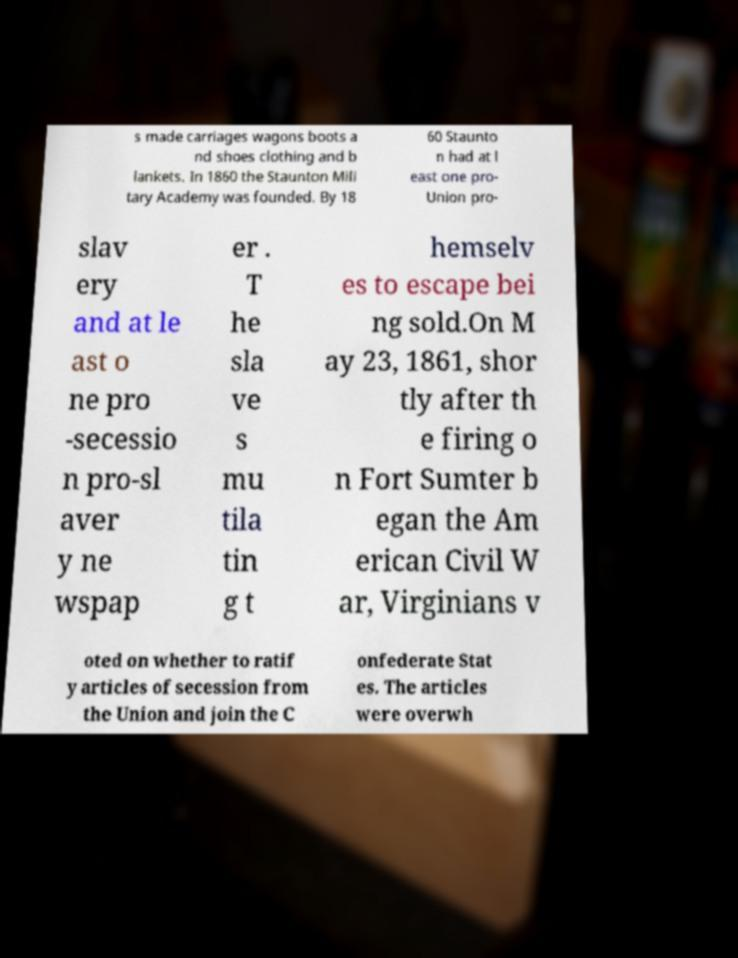For documentation purposes, I need the text within this image transcribed. Could you provide that? s made carriages wagons boots a nd shoes clothing and b lankets. In 1860 the Staunton Mili tary Academy was founded. By 18 60 Staunto n had at l east one pro- Union pro- slav ery and at le ast o ne pro -secessio n pro-sl aver y ne wspap er . T he sla ve s mu tila tin g t hemselv es to escape bei ng sold.On M ay 23, 1861, shor tly after th e firing o n Fort Sumter b egan the Am erican Civil W ar, Virginians v oted on whether to ratif y articles of secession from the Union and join the C onfederate Stat es. The articles were overwh 